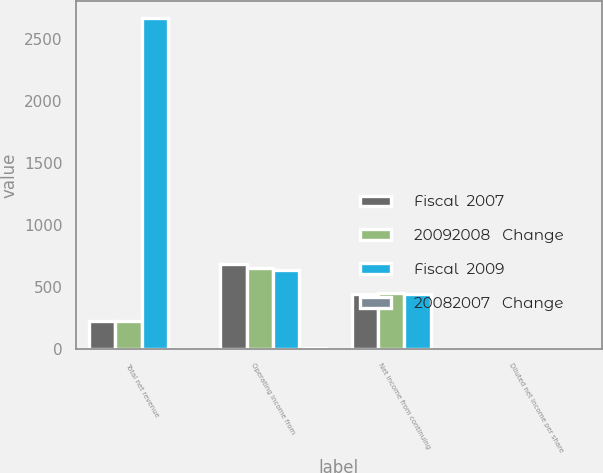Convert chart to OTSL. <chart><loc_0><loc_0><loc_500><loc_500><stacked_bar_chart><ecel><fcel>Total net revenue<fcel>Operating income from<fcel>Net income from continuing<fcel>Diluted net income per share<nl><fcel>Fiscal  2007<fcel>224.25<fcel>682.1<fcel>447<fcel>1.35<nl><fcel>20092008   Change<fcel>224.25<fcel>650.8<fcel>450.8<fcel>1.33<nl><fcel>Fiscal  2009<fcel>2672.9<fcel>637.6<fcel>443.5<fcel>1.25<nl><fcel>20082007   Change<fcel>4<fcel>5<fcel>1<fcel>2<nl></chart> 